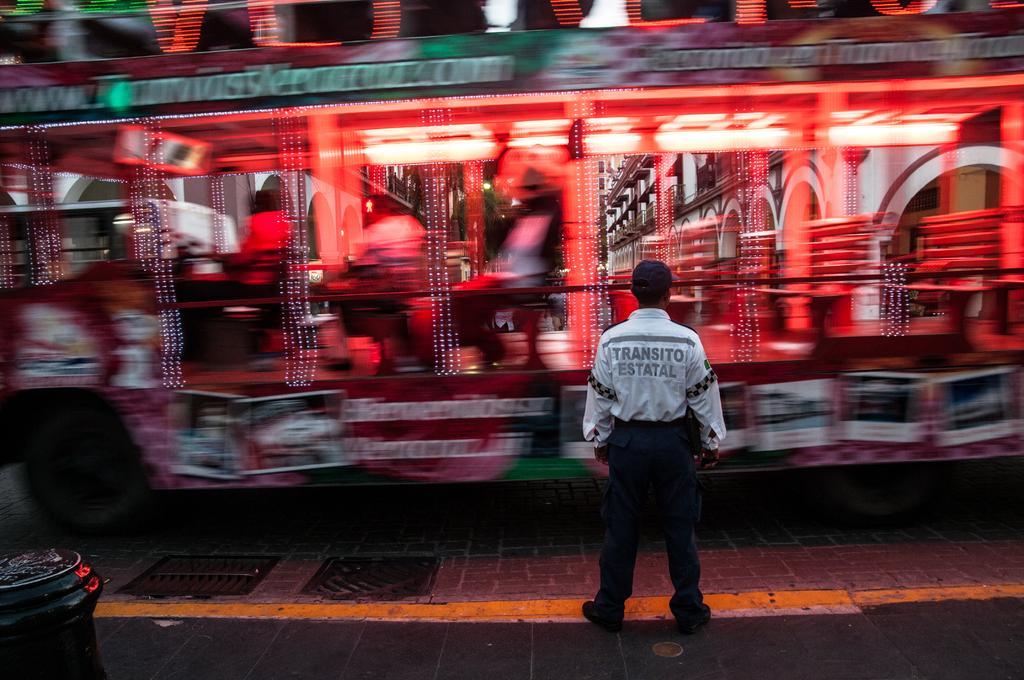Can you describe this image briefly? In the center of the image, we can see a bus on the road and in the front, we can see a person standing and wearing cap and there is a bin. 